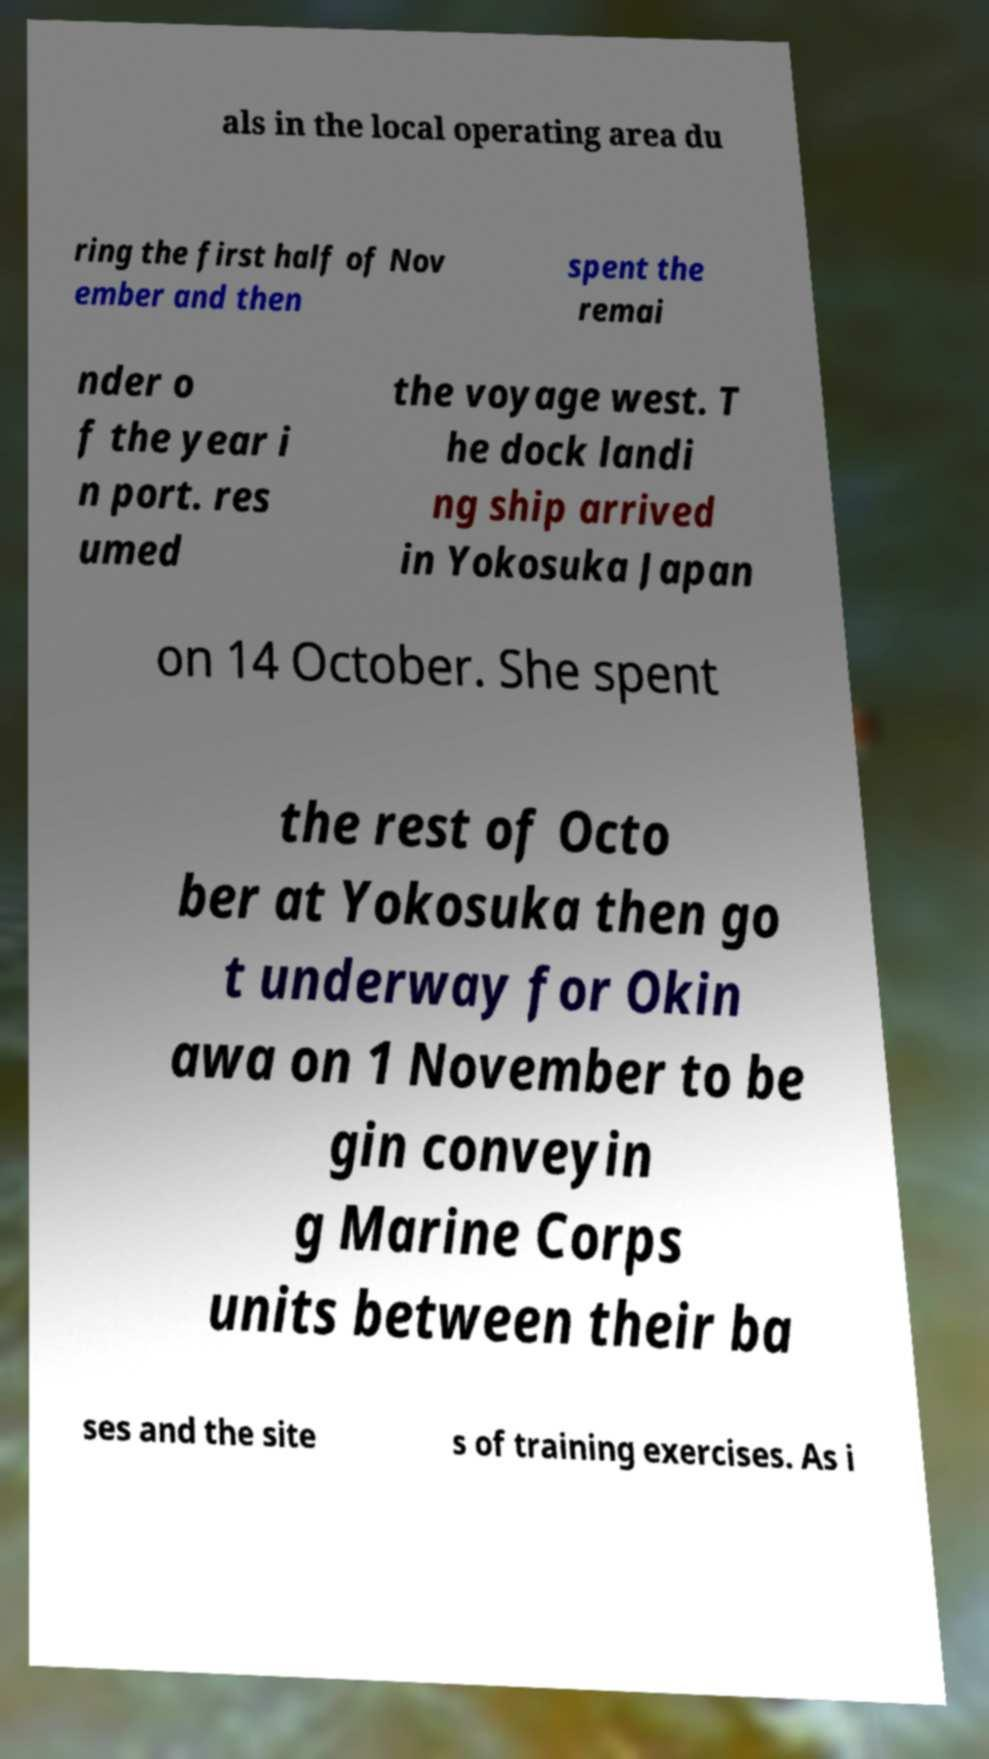Can you accurately transcribe the text from the provided image for me? als in the local operating area du ring the first half of Nov ember and then spent the remai nder o f the year i n port. res umed the voyage west. T he dock landi ng ship arrived in Yokosuka Japan on 14 October. She spent the rest of Octo ber at Yokosuka then go t underway for Okin awa on 1 November to be gin conveyin g Marine Corps units between their ba ses and the site s of training exercises. As i 